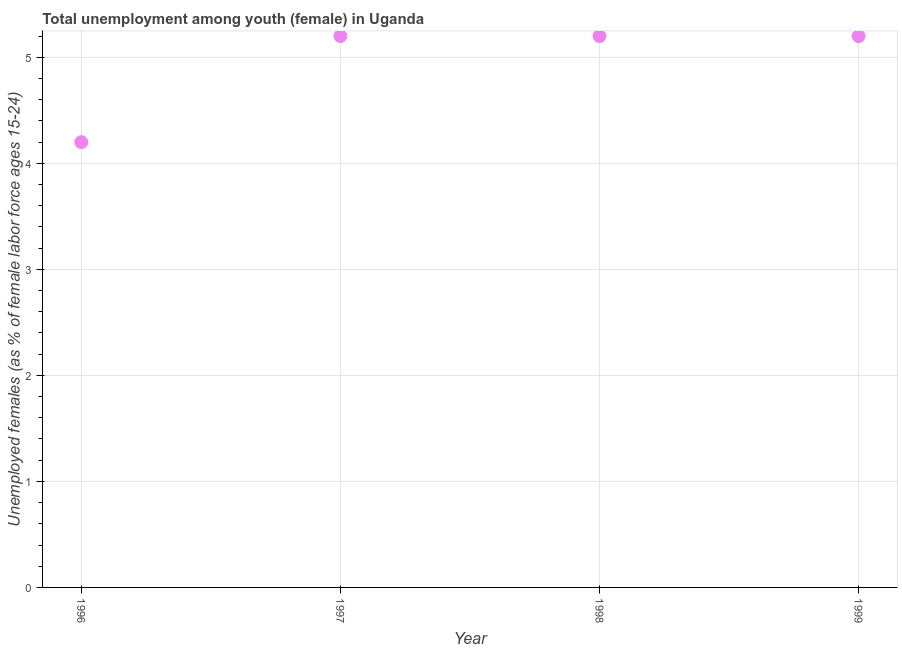What is the unemployed female youth population in 1996?
Provide a succinct answer. 4.2. Across all years, what is the maximum unemployed female youth population?
Offer a very short reply. 5.2. Across all years, what is the minimum unemployed female youth population?
Your response must be concise. 4.2. What is the sum of the unemployed female youth population?
Your response must be concise. 19.8. What is the difference between the unemployed female youth population in 1996 and 1999?
Offer a terse response. -1. What is the average unemployed female youth population per year?
Give a very brief answer. 4.95. What is the median unemployed female youth population?
Provide a succinct answer. 5.2. What is the ratio of the unemployed female youth population in 1996 to that in 1999?
Keep it short and to the point. 0.81. Is the unemployed female youth population in 1996 less than that in 1998?
Provide a succinct answer. Yes. What is the difference between the highest and the second highest unemployed female youth population?
Keep it short and to the point. 0. Is the sum of the unemployed female youth population in 1997 and 1998 greater than the maximum unemployed female youth population across all years?
Your answer should be very brief. Yes. What is the difference between the highest and the lowest unemployed female youth population?
Make the answer very short. 1. How many years are there in the graph?
Provide a succinct answer. 4. What is the difference between two consecutive major ticks on the Y-axis?
Offer a terse response. 1. Does the graph contain grids?
Your response must be concise. Yes. What is the title of the graph?
Keep it short and to the point. Total unemployment among youth (female) in Uganda. What is the label or title of the X-axis?
Give a very brief answer. Year. What is the label or title of the Y-axis?
Your response must be concise. Unemployed females (as % of female labor force ages 15-24). What is the Unemployed females (as % of female labor force ages 15-24) in 1996?
Give a very brief answer. 4.2. What is the Unemployed females (as % of female labor force ages 15-24) in 1997?
Ensure brevity in your answer.  5.2. What is the Unemployed females (as % of female labor force ages 15-24) in 1998?
Your response must be concise. 5.2. What is the Unemployed females (as % of female labor force ages 15-24) in 1999?
Make the answer very short. 5.2. What is the difference between the Unemployed females (as % of female labor force ages 15-24) in 1996 and 1997?
Offer a very short reply. -1. What is the ratio of the Unemployed females (as % of female labor force ages 15-24) in 1996 to that in 1997?
Offer a terse response. 0.81. What is the ratio of the Unemployed females (as % of female labor force ages 15-24) in 1996 to that in 1998?
Provide a short and direct response. 0.81. What is the ratio of the Unemployed females (as % of female labor force ages 15-24) in 1996 to that in 1999?
Provide a succinct answer. 0.81. What is the ratio of the Unemployed females (as % of female labor force ages 15-24) in 1997 to that in 1998?
Your answer should be compact. 1. What is the ratio of the Unemployed females (as % of female labor force ages 15-24) in 1997 to that in 1999?
Keep it short and to the point. 1. 